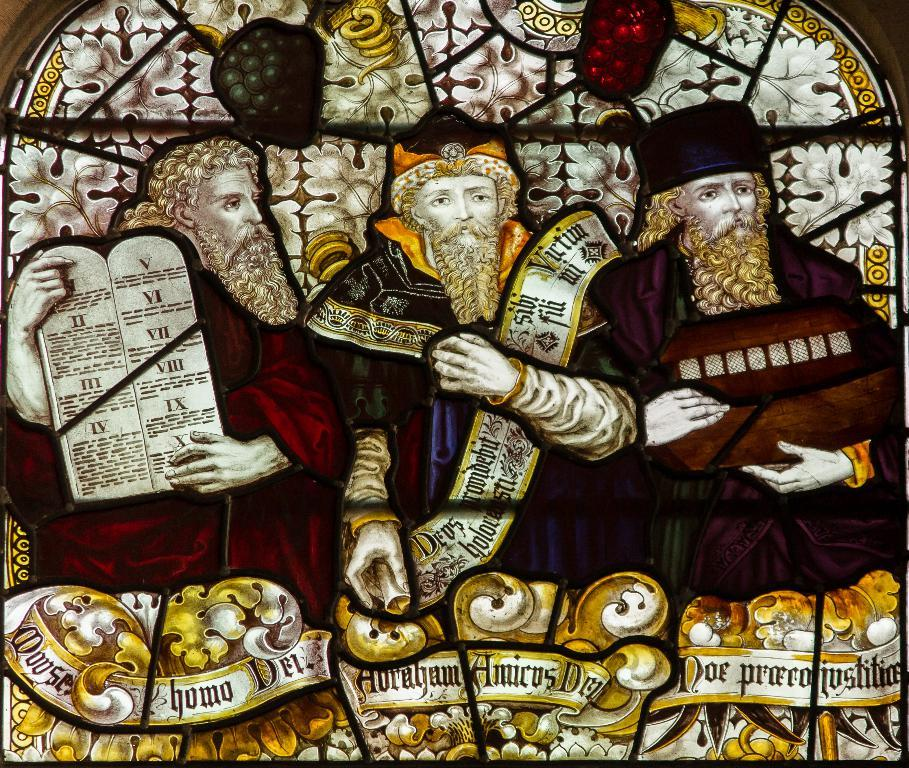What type of glass is featured in the image? There is stained glass in the image. What can be seen on the stained glass? The stained glass has designs of persons on it. What type of jeans are being worn by the person in the image? There are no jeans present in the image, as it only features stained glass with designs of persons. How does the knife interact with the stained glass in the image? There is no knife present in the image, so it cannot interact with the stained glass. 